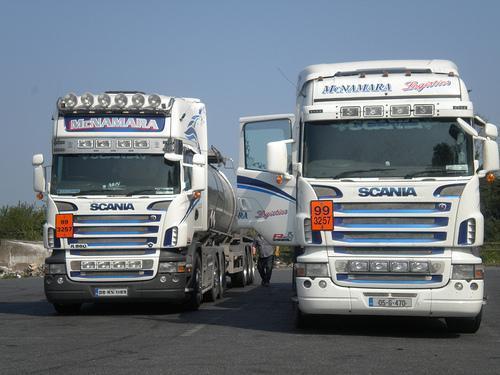How many trucks are in the photo?
Give a very brief answer. 2. 